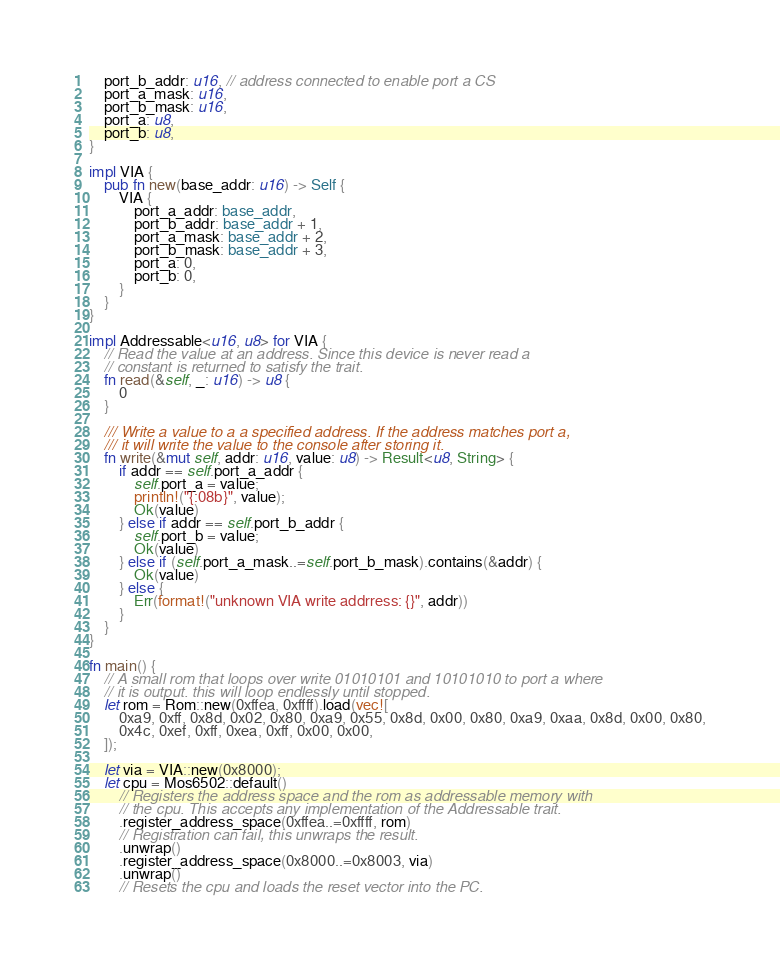<code> <loc_0><loc_0><loc_500><loc_500><_Rust_>    port_b_addr: u16, // address connected to enable port a CS
    port_a_mask: u16,
    port_b_mask: u16,
    port_a: u8,
    port_b: u8,
}

impl VIA {
    pub fn new(base_addr: u16) -> Self {
        VIA {
            port_a_addr: base_addr,
            port_b_addr: base_addr + 1,
            port_a_mask: base_addr + 2,
            port_b_mask: base_addr + 3,
            port_a: 0,
            port_b: 0,
        }
    }
}

impl Addressable<u16, u8> for VIA {
    // Read the value at an address. Since this device is never read a
    // constant is returned to satisfy the trait.
    fn read(&self, _: u16) -> u8 {
        0
    }

    /// Write a value to a a specified address. If the address matches port a,
    /// it will write the value to the console after storing it.
    fn write(&mut self, addr: u16, value: u8) -> Result<u8, String> {
        if addr == self.port_a_addr {
            self.port_a = value;
            println!("{:08b}", value);
            Ok(value)
        } else if addr == self.port_b_addr {
            self.port_b = value;
            Ok(value)
        } else if (self.port_a_mask..=self.port_b_mask).contains(&addr) {
            Ok(value)
        } else {
            Err(format!("unknown VIA write addrress: {}", addr))
        }
    }
}

fn main() {
    // A small rom that loops over write 01010101 and 10101010 to port a where
    // it is output. this will loop endlessly until stopped.
    let rom = Rom::new(0xffea, 0xffff).load(vec![
        0xa9, 0xff, 0x8d, 0x02, 0x80, 0xa9, 0x55, 0x8d, 0x00, 0x80, 0xa9, 0xaa, 0x8d, 0x00, 0x80,
        0x4c, 0xef, 0xff, 0xea, 0xff, 0x00, 0x00,
    ]);

    let via = VIA::new(0x8000);
    let cpu = Mos6502::default()
        // Registers the address space and the rom as addressable memory with
        // the cpu. This accepts any implementation of the Addressable trait.
        .register_address_space(0xffea..=0xffff, rom)
        // Registration can fail, this unwraps the result.
        .unwrap()
        .register_address_space(0x8000..=0x8003, via)
        .unwrap()
        // Resets the cpu and loads the reset vector into the PC.</code> 